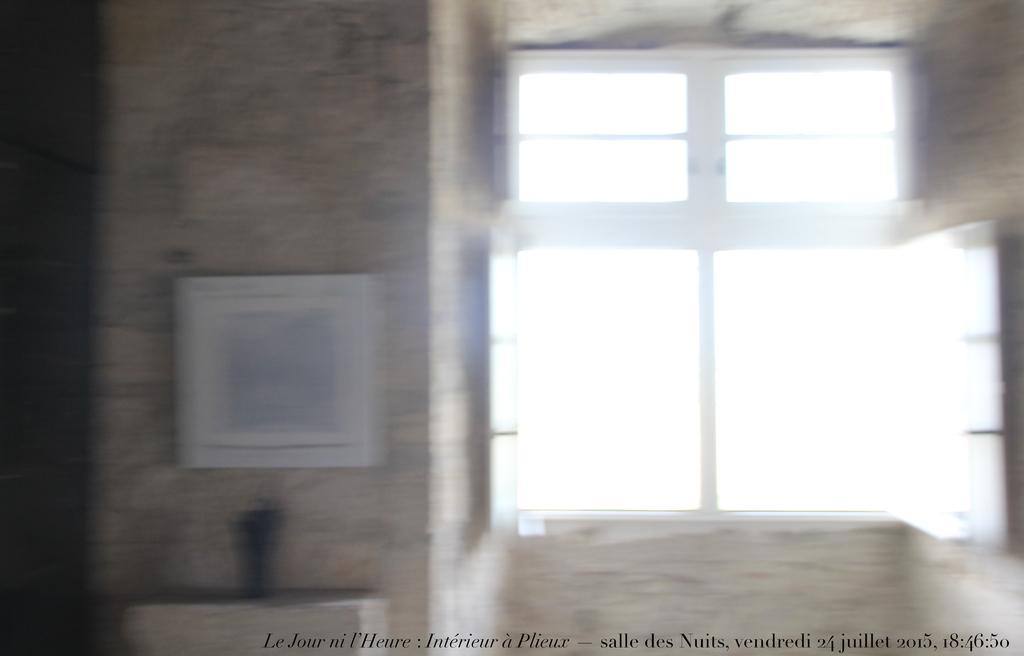What architectural feature is visible in the image? There is a window in the image. Where is the window located in relation to other objects? The window is near a pillar. What type of decorative items can be seen in the image? There are photo frames in the image. Where are the photo frames located in relation to other objects? The photo frames are near a table. What book is the person reading in the image? There is no person or book visible in the image. What part of the spy's mission is depicted in the image? There is no spy or mission depicted in the image. 